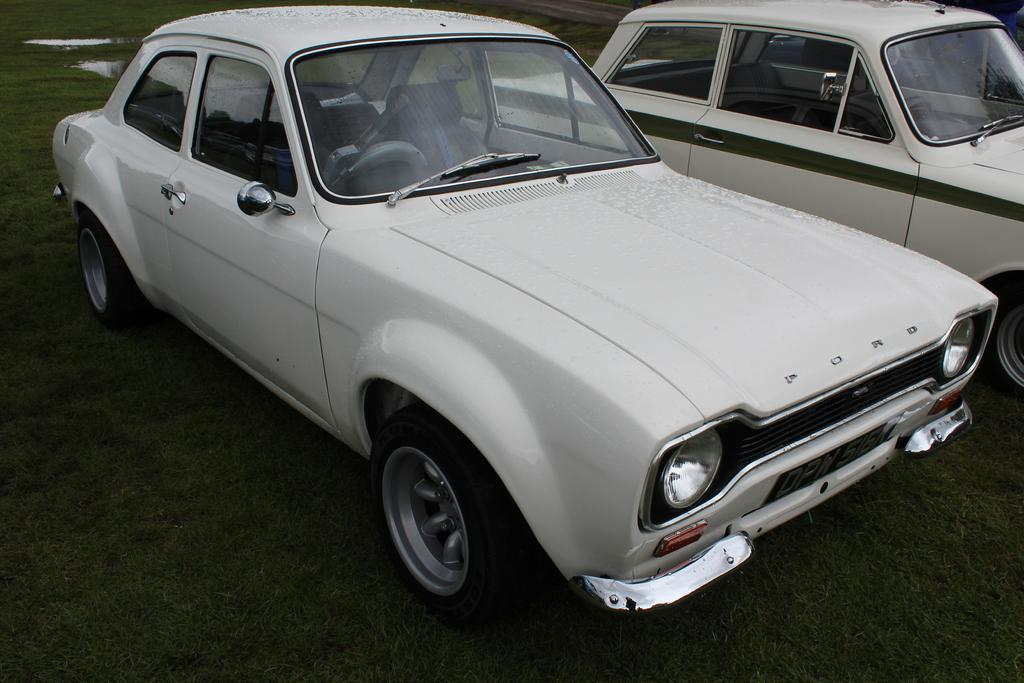How many cars are present in the image? There are 2 cars in the image. What color are the cars? The cars are white in color. Can you identify any text or words in the image? Yes, there is a word visible in the image. What type of natural environment is depicted in the image? There is green grass and water visible in the image. Reasoning: Let' Let's think step by step in order to produce the conversation. We start by identifying the main subjects in the image, which are the cars. Then, we describe their color and any other notable features. Next, we mention the presence of text or words in the image. Finally, we describe the natural environment depicted in the image, which includes green grass and water. Absurd Question/Answer: Where is the cactus located in the image? There is no cactus present in the image. What type of kettle is visible in the image? There is no kettle visible in the image. 